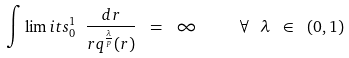Convert formula to latex. <formula><loc_0><loc_0><loc_500><loc_500>\int \lim i t s _ { 0 } ^ { 1 } \ \frac { d r } { r q ^ { \frac { \lambda } { p } } ( r ) } \ = \ \infty \quad \ \forall \ \lambda \ \in \ ( 0 , 1 )</formula> 